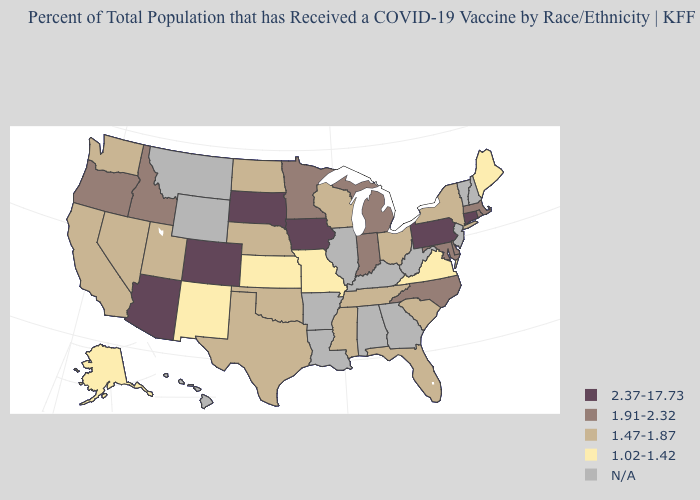What is the lowest value in the West?
Be succinct. 1.02-1.42. How many symbols are there in the legend?
Be succinct. 5. Among the states that border Kentucky , does Indiana have the lowest value?
Concise answer only. No. What is the value of Massachusetts?
Give a very brief answer. 1.91-2.32. What is the value of Minnesota?
Quick response, please. 1.91-2.32. What is the lowest value in the South?
Quick response, please. 1.02-1.42. Name the states that have a value in the range N/A?
Be succinct. Alabama, Arkansas, Georgia, Hawaii, Illinois, Kentucky, Louisiana, Montana, New Hampshire, New Jersey, Vermont, West Virginia, Wyoming. What is the value of Pennsylvania?
Concise answer only. 2.37-17.73. Name the states that have a value in the range 1.02-1.42?
Short answer required. Alaska, Kansas, Maine, Missouri, New Mexico, Virginia. Which states have the lowest value in the West?
Keep it brief. Alaska, New Mexico. Does Virginia have the lowest value in the South?
Write a very short answer. Yes. 